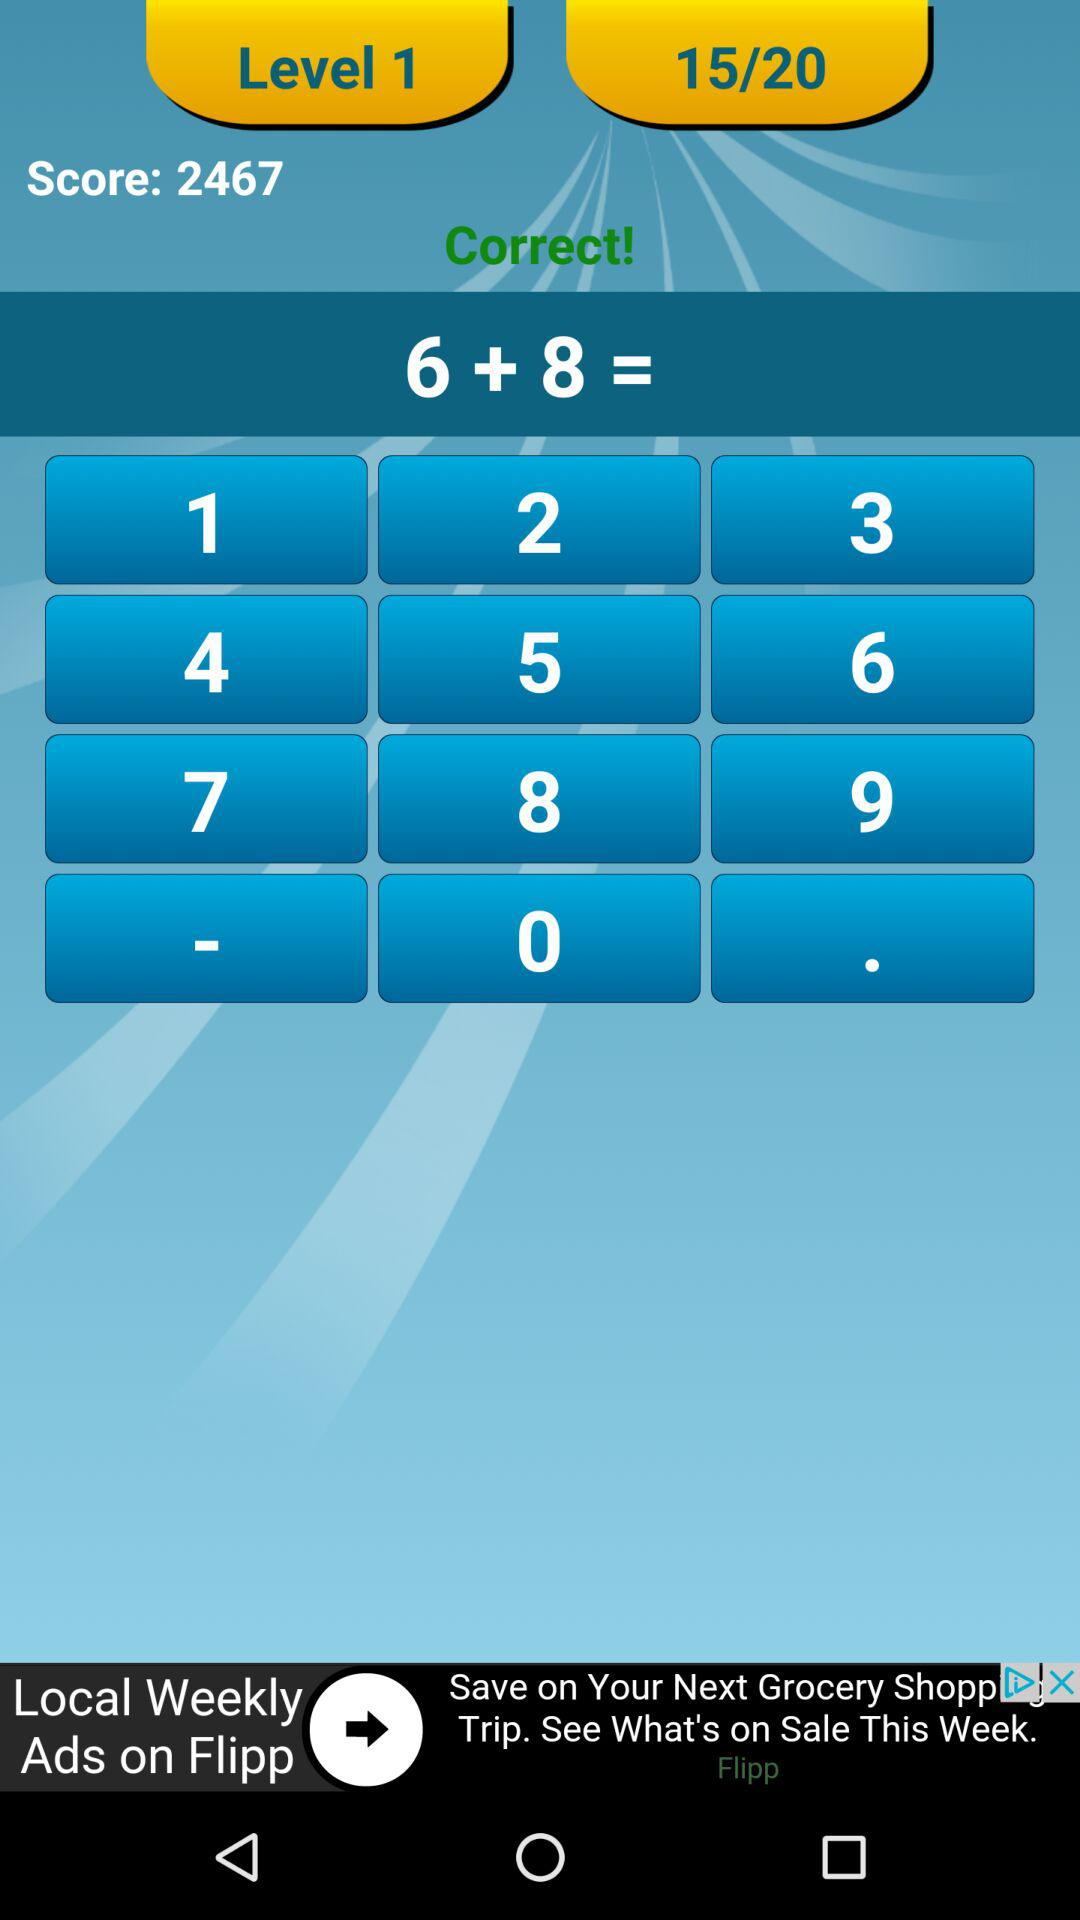What level is this? This is level 1. 